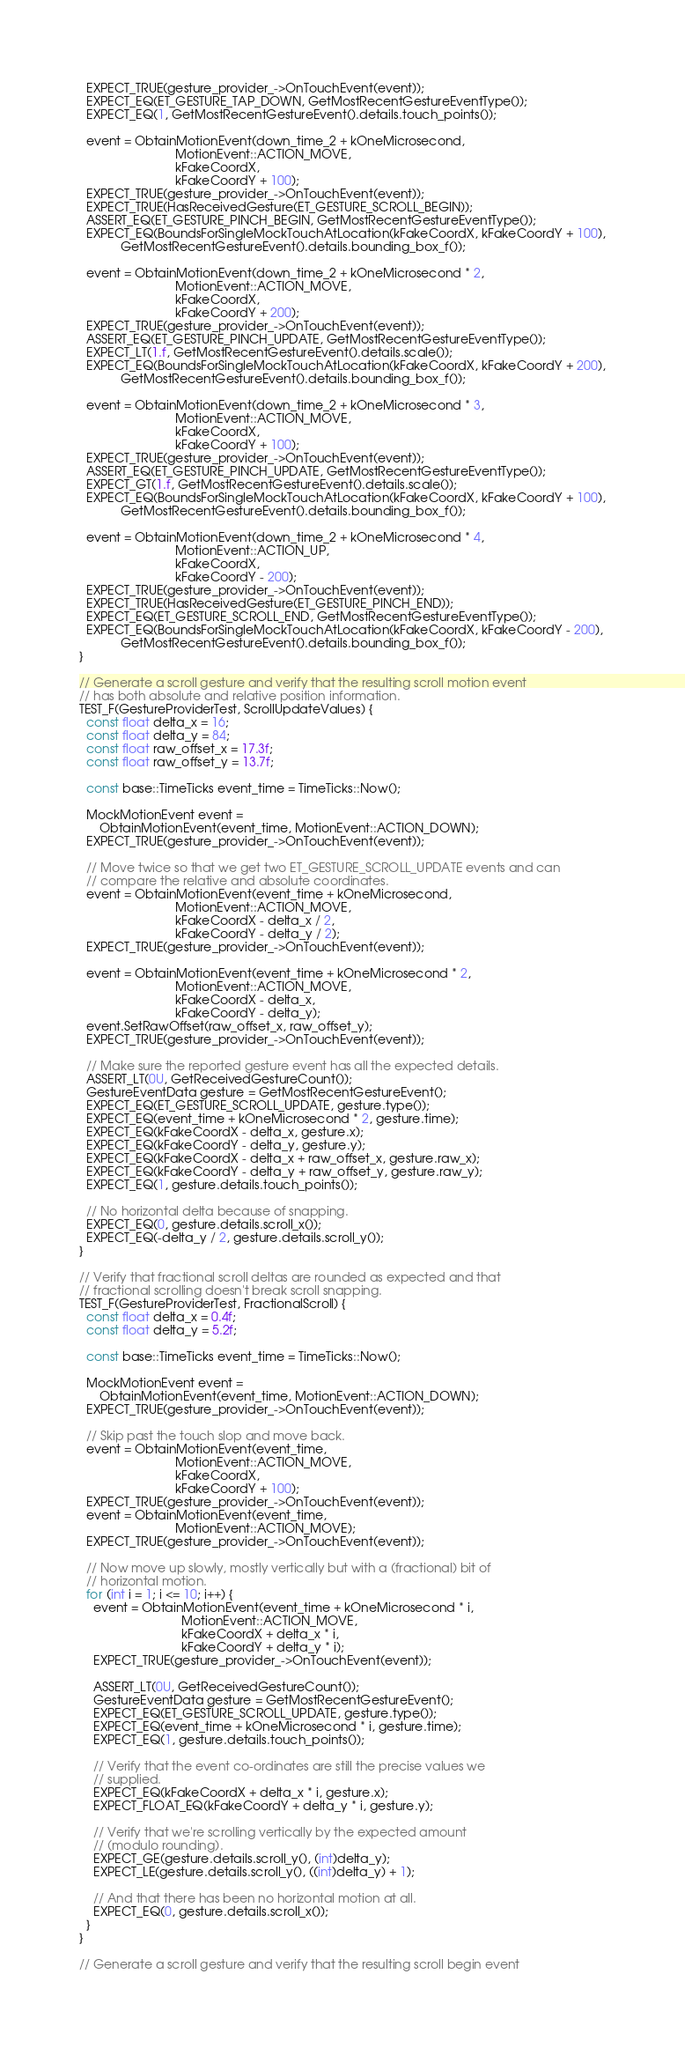Convert code to text. <code><loc_0><loc_0><loc_500><loc_500><_C++_>  EXPECT_TRUE(gesture_provider_->OnTouchEvent(event));
  EXPECT_EQ(ET_GESTURE_TAP_DOWN, GetMostRecentGestureEventType());
  EXPECT_EQ(1, GetMostRecentGestureEvent().details.touch_points());

  event = ObtainMotionEvent(down_time_2 + kOneMicrosecond,
                            MotionEvent::ACTION_MOVE,
                            kFakeCoordX,
                            kFakeCoordY + 100);
  EXPECT_TRUE(gesture_provider_->OnTouchEvent(event));
  EXPECT_TRUE(HasReceivedGesture(ET_GESTURE_SCROLL_BEGIN));
  ASSERT_EQ(ET_GESTURE_PINCH_BEGIN, GetMostRecentGestureEventType());
  EXPECT_EQ(BoundsForSingleMockTouchAtLocation(kFakeCoordX, kFakeCoordY + 100),
            GetMostRecentGestureEvent().details.bounding_box_f());

  event = ObtainMotionEvent(down_time_2 + kOneMicrosecond * 2,
                            MotionEvent::ACTION_MOVE,
                            kFakeCoordX,
                            kFakeCoordY + 200);
  EXPECT_TRUE(gesture_provider_->OnTouchEvent(event));
  ASSERT_EQ(ET_GESTURE_PINCH_UPDATE, GetMostRecentGestureEventType());
  EXPECT_LT(1.f, GetMostRecentGestureEvent().details.scale());
  EXPECT_EQ(BoundsForSingleMockTouchAtLocation(kFakeCoordX, kFakeCoordY + 200),
            GetMostRecentGestureEvent().details.bounding_box_f());

  event = ObtainMotionEvent(down_time_2 + kOneMicrosecond * 3,
                            MotionEvent::ACTION_MOVE,
                            kFakeCoordX,
                            kFakeCoordY + 100);
  EXPECT_TRUE(gesture_provider_->OnTouchEvent(event));
  ASSERT_EQ(ET_GESTURE_PINCH_UPDATE, GetMostRecentGestureEventType());
  EXPECT_GT(1.f, GetMostRecentGestureEvent().details.scale());
  EXPECT_EQ(BoundsForSingleMockTouchAtLocation(kFakeCoordX, kFakeCoordY + 100),
            GetMostRecentGestureEvent().details.bounding_box_f());

  event = ObtainMotionEvent(down_time_2 + kOneMicrosecond * 4,
                            MotionEvent::ACTION_UP,
                            kFakeCoordX,
                            kFakeCoordY - 200);
  EXPECT_TRUE(gesture_provider_->OnTouchEvent(event));
  EXPECT_TRUE(HasReceivedGesture(ET_GESTURE_PINCH_END));
  EXPECT_EQ(ET_GESTURE_SCROLL_END, GetMostRecentGestureEventType());
  EXPECT_EQ(BoundsForSingleMockTouchAtLocation(kFakeCoordX, kFakeCoordY - 200),
            GetMostRecentGestureEvent().details.bounding_box_f());
}

// Generate a scroll gesture and verify that the resulting scroll motion event
// has both absolute and relative position information.
TEST_F(GestureProviderTest, ScrollUpdateValues) {
  const float delta_x = 16;
  const float delta_y = 84;
  const float raw_offset_x = 17.3f;
  const float raw_offset_y = 13.7f;

  const base::TimeTicks event_time = TimeTicks::Now();

  MockMotionEvent event =
      ObtainMotionEvent(event_time, MotionEvent::ACTION_DOWN);
  EXPECT_TRUE(gesture_provider_->OnTouchEvent(event));

  // Move twice so that we get two ET_GESTURE_SCROLL_UPDATE events and can
  // compare the relative and absolute coordinates.
  event = ObtainMotionEvent(event_time + kOneMicrosecond,
                            MotionEvent::ACTION_MOVE,
                            kFakeCoordX - delta_x / 2,
                            kFakeCoordY - delta_y / 2);
  EXPECT_TRUE(gesture_provider_->OnTouchEvent(event));

  event = ObtainMotionEvent(event_time + kOneMicrosecond * 2,
                            MotionEvent::ACTION_MOVE,
                            kFakeCoordX - delta_x,
                            kFakeCoordY - delta_y);
  event.SetRawOffset(raw_offset_x, raw_offset_y);
  EXPECT_TRUE(gesture_provider_->OnTouchEvent(event));

  // Make sure the reported gesture event has all the expected details.
  ASSERT_LT(0U, GetReceivedGestureCount());
  GestureEventData gesture = GetMostRecentGestureEvent();
  EXPECT_EQ(ET_GESTURE_SCROLL_UPDATE, gesture.type());
  EXPECT_EQ(event_time + kOneMicrosecond * 2, gesture.time);
  EXPECT_EQ(kFakeCoordX - delta_x, gesture.x);
  EXPECT_EQ(kFakeCoordY - delta_y, gesture.y);
  EXPECT_EQ(kFakeCoordX - delta_x + raw_offset_x, gesture.raw_x);
  EXPECT_EQ(kFakeCoordY - delta_y + raw_offset_y, gesture.raw_y);
  EXPECT_EQ(1, gesture.details.touch_points());

  // No horizontal delta because of snapping.
  EXPECT_EQ(0, gesture.details.scroll_x());
  EXPECT_EQ(-delta_y / 2, gesture.details.scroll_y());
}

// Verify that fractional scroll deltas are rounded as expected and that
// fractional scrolling doesn't break scroll snapping.
TEST_F(GestureProviderTest, FractionalScroll) {
  const float delta_x = 0.4f;
  const float delta_y = 5.2f;

  const base::TimeTicks event_time = TimeTicks::Now();

  MockMotionEvent event =
      ObtainMotionEvent(event_time, MotionEvent::ACTION_DOWN);
  EXPECT_TRUE(gesture_provider_->OnTouchEvent(event));

  // Skip past the touch slop and move back.
  event = ObtainMotionEvent(event_time,
                            MotionEvent::ACTION_MOVE,
                            kFakeCoordX,
                            kFakeCoordY + 100);
  EXPECT_TRUE(gesture_provider_->OnTouchEvent(event));
  event = ObtainMotionEvent(event_time,
                            MotionEvent::ACTION_MOVE);
  EXPECT_TRUE(gesture_provider_->OnTouchEvent(event));

  // Now move up slowly, mostly vertically but with a (fractional) bit of
  // horizontal motion.
  for (int i = 1; i <= 10; i++) {
    event = ObtainMotionEvent(event_time + kOneMicrosecond * i,
                              MotionEvent::ACTION_MOVE,
                              kFakeCoordX + delta_x * i,
                              kFakeCoordY + delta_y * i);
    EXPECT_TRUE(gesture_provider_->OnTouchEvent(event));

    ASSERT_LT(0U, GetReceivedGestureCount());
    GestureEventData gesture = GetMostRecentGestureEvent();
    EXPECT_EQ(ET_GESTURE_SCROLL_UPDATE, gesture.type());
    EXPECT_EQ(event_time + kOneMicrosecond * i, gesture.time);
    EXPECT_EQ(1, gesture.details.touch_points());

    // Verify that the event co-ordinates are still the precise values we
    // supplied.
    EXPECT_EQ(kFakeCoordX + delta_x * i, gesture.x);
    EXPECT_FLOAT_EQ(kFakeCoordY + delta_y * i, gesture.y);

    // Verify that we're scrolling vertically by the expected amount
    // (modulo rounding).
    EXPECT_GE(gesture.details.scroll_y(), (int)delta_y);
    EXPECT_LE(gesture.details.scroll_y(), ((int)delta_y) + 1);

    // And that there has been no horizontal motion at all.
    EXPECT_EQ(0, gesture.details.scroll_x());
  }
}

// Generate a scroll gesture and verify that the resulting scroll begin event</code> 